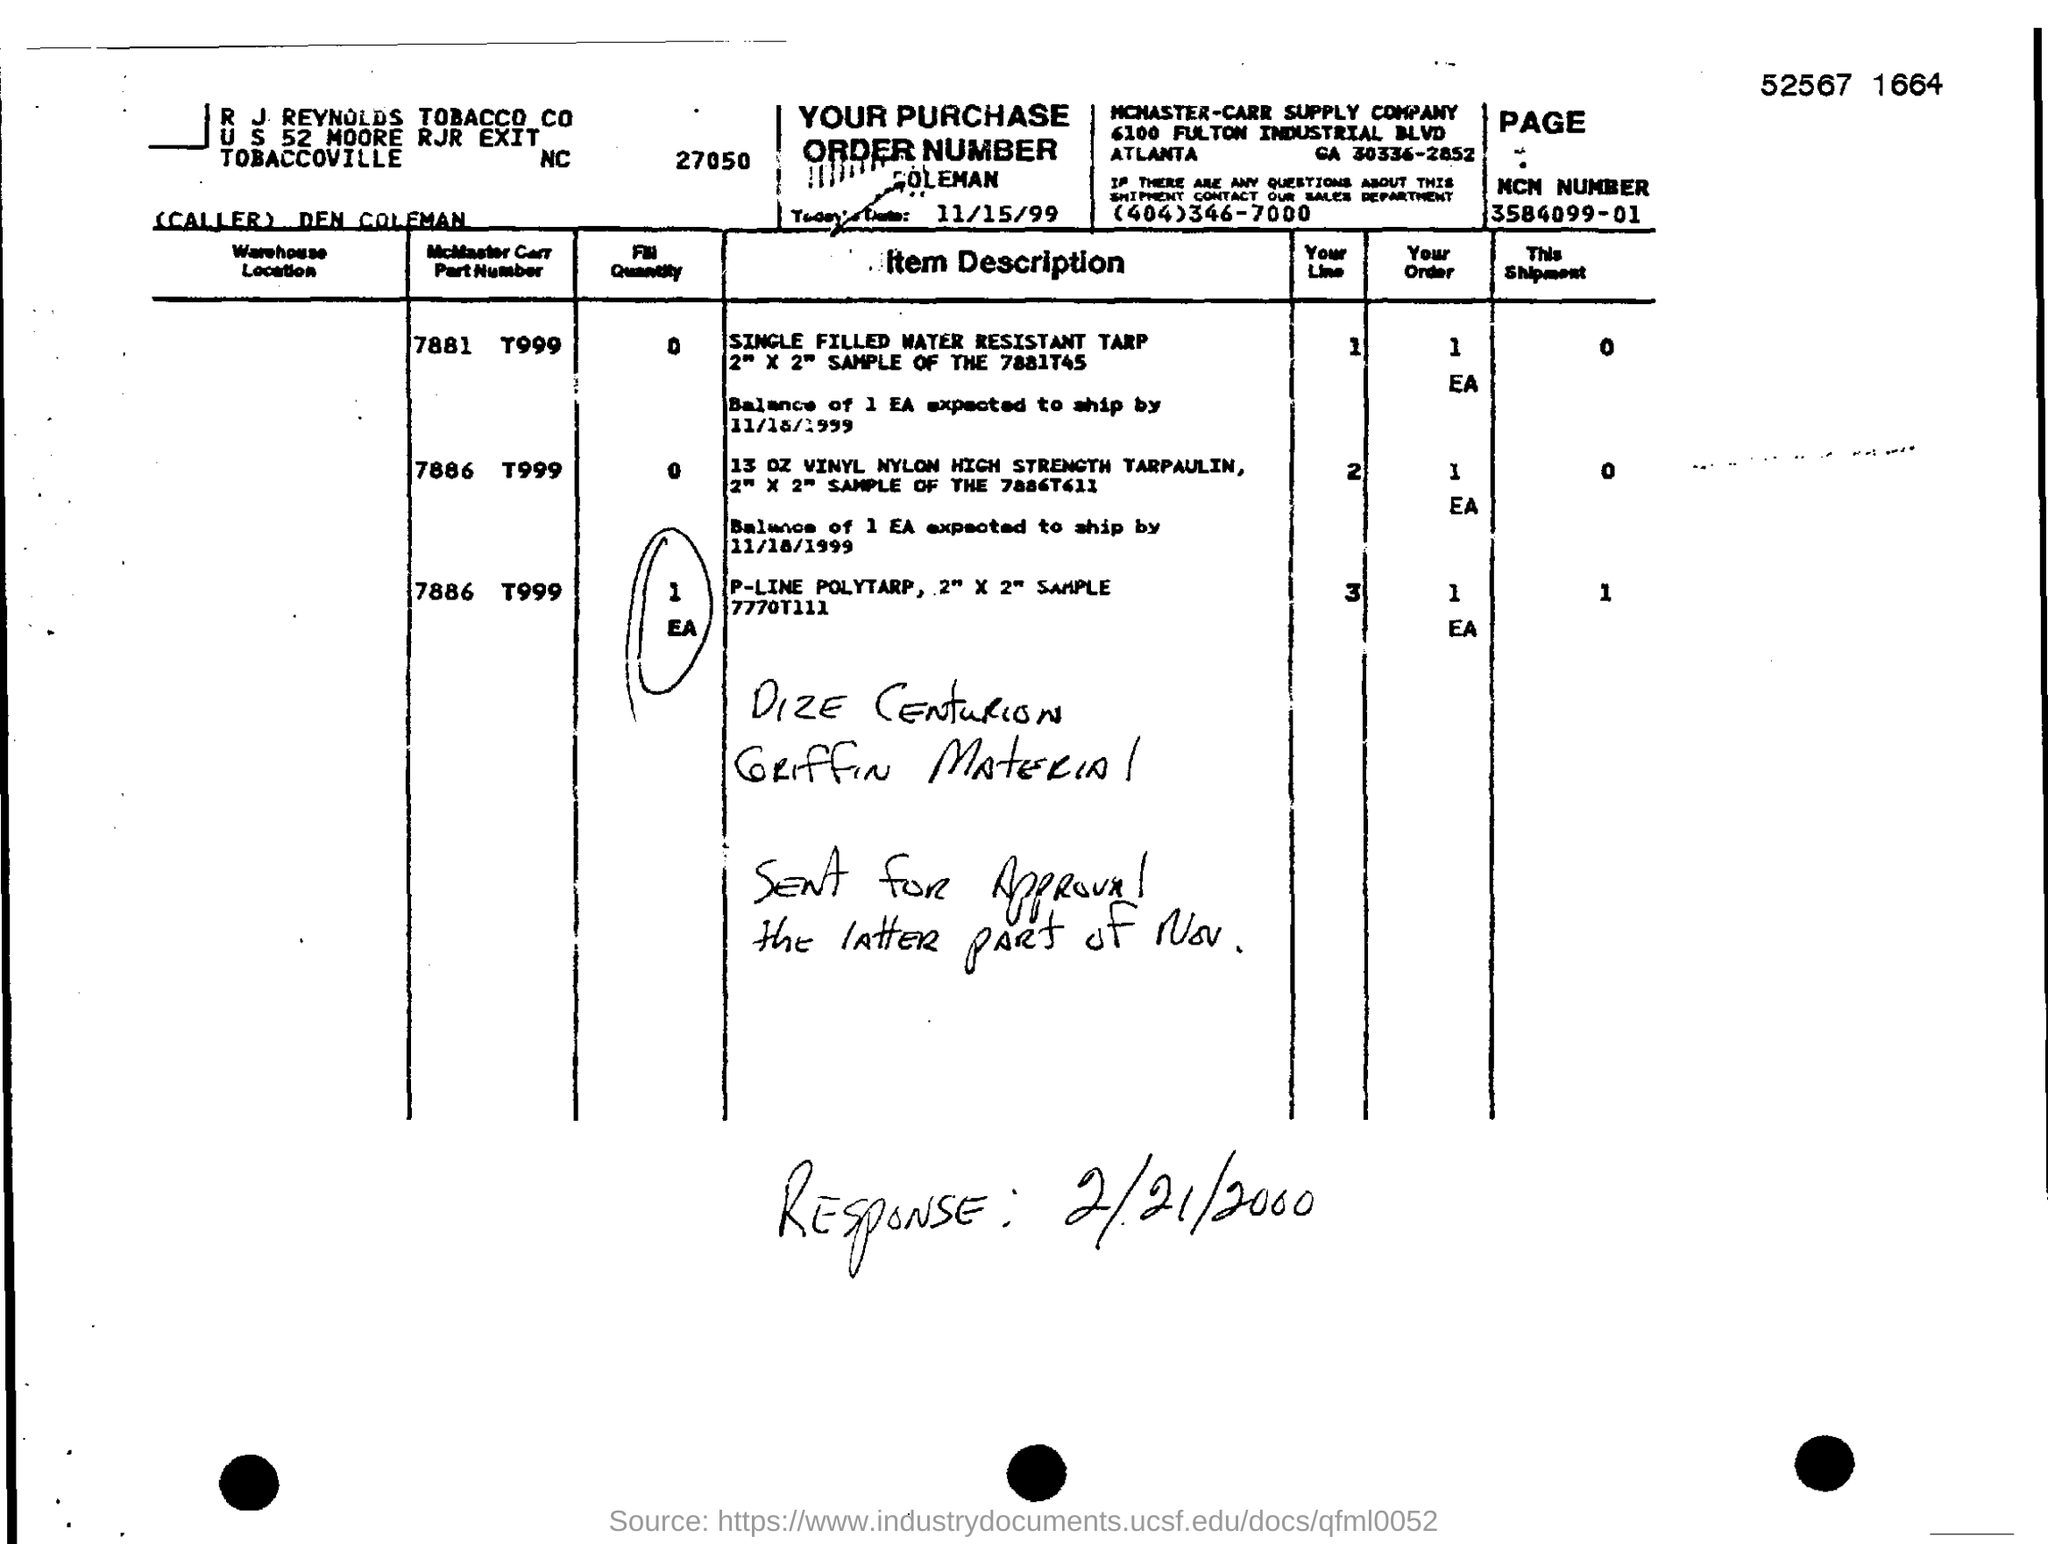Highlight a few significant elements in this photo. The MCN number is a unique identifier assigned to a specific motor vehicle, which consists of 17 digits, including a letter and a hyphen. The first nine digits represent the manufacturer's code, the next four digits indicate the model year, and the final four digits indicate the assembly plant where the vehicle was produced. The date of the purchase order is November 15, 1999. 